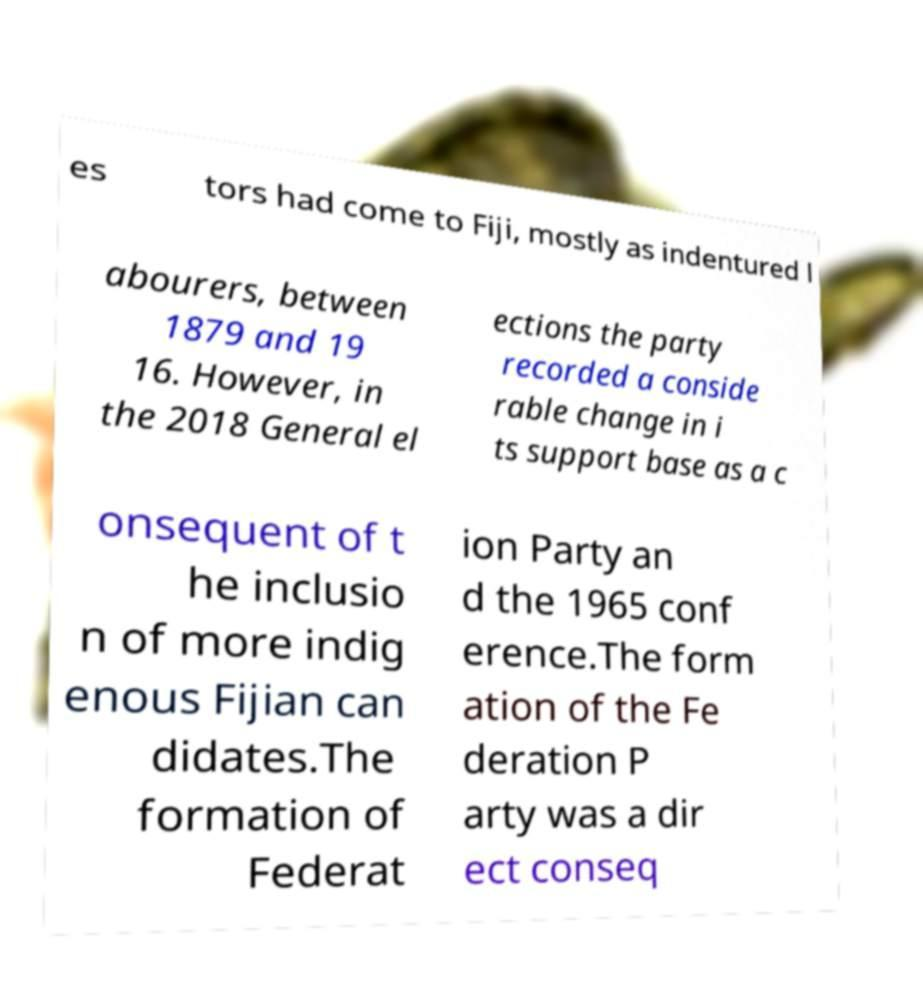Could you extract and type out the text from this image? es tors had come to Fiji, mostly as indentured l abourers, between 1879 and 19 16. However, in the 2018 General el ections the party recorded a conside rable change in i ts support base as a c onsequent of t he inclusio n of more indig enous Fijian can didates.The formation of Federat ion Party an d the 1965 conf erence.The form ation of the Fe deration P arty was a dir ect conseq 